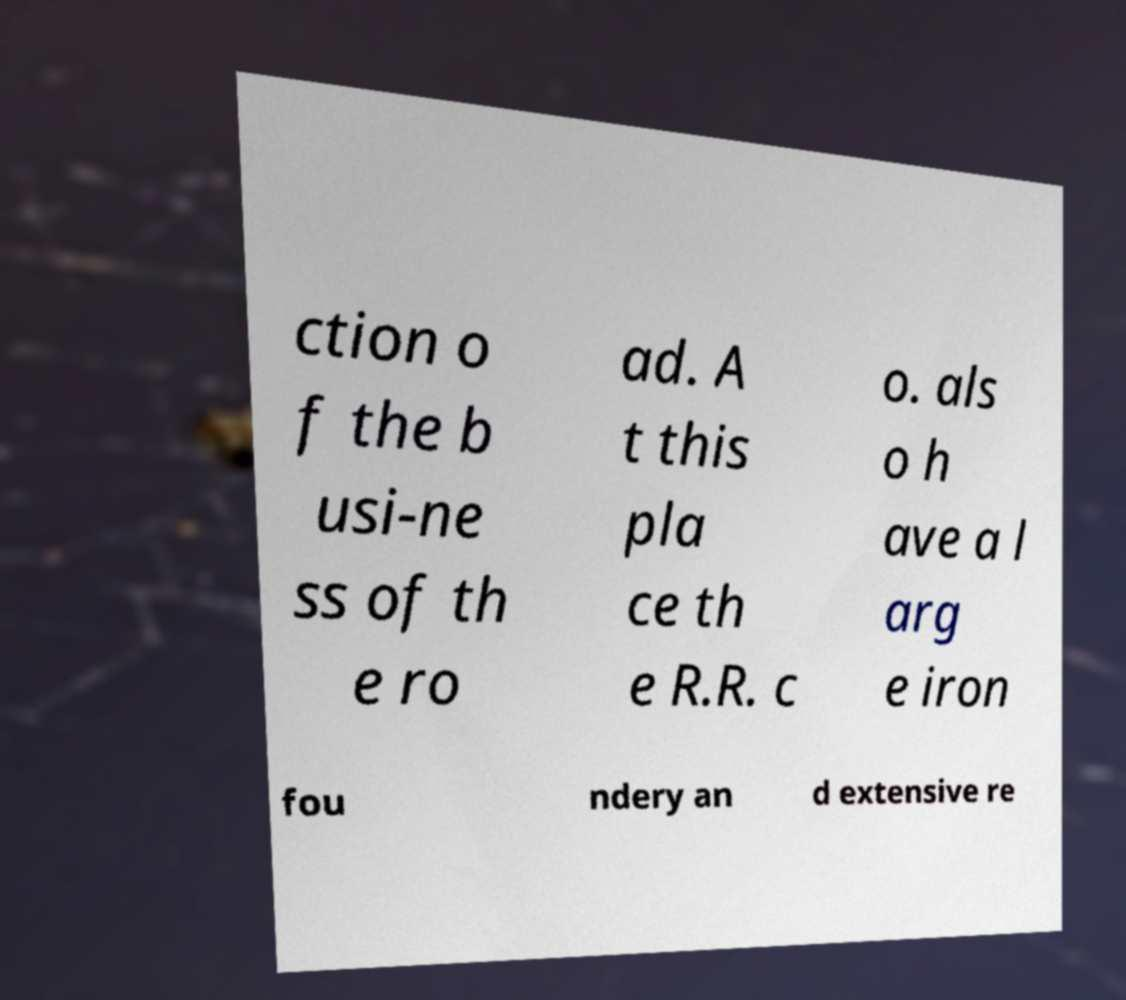Can you read and provide the text displayed in the image?This photo seems to have some interesting text. Can you extract and type it out for me? ction o f the b usi-ne ss of th e ro ad. A t this pla ce th e R.R. c o. als o h ave a l arg e iron fou ndery an d extensive re 